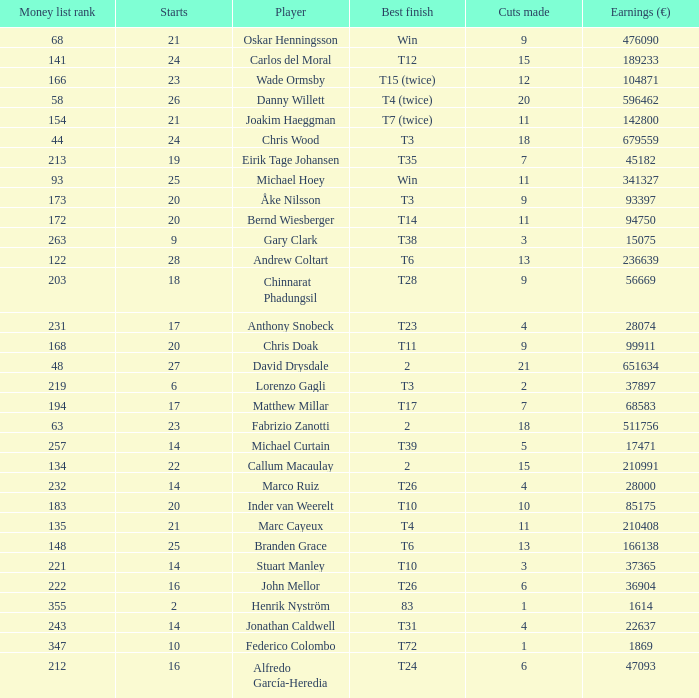How many cuts did the player who earned 210408 Euro make? 11.0. 